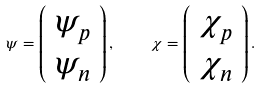Convert formula to latex. <formula><loc_0><loc_0><loc_500><loc_500>\psi = \left ( \begin{array} { c c } \psi _ { p } \\ \psi _ { n } \end{array} \right ) , \quad \chi = \left ( \begin{array} { c c } \chi _ { p } \\ \chi _ { n } \end{array} \right ) . \quad</formula> 